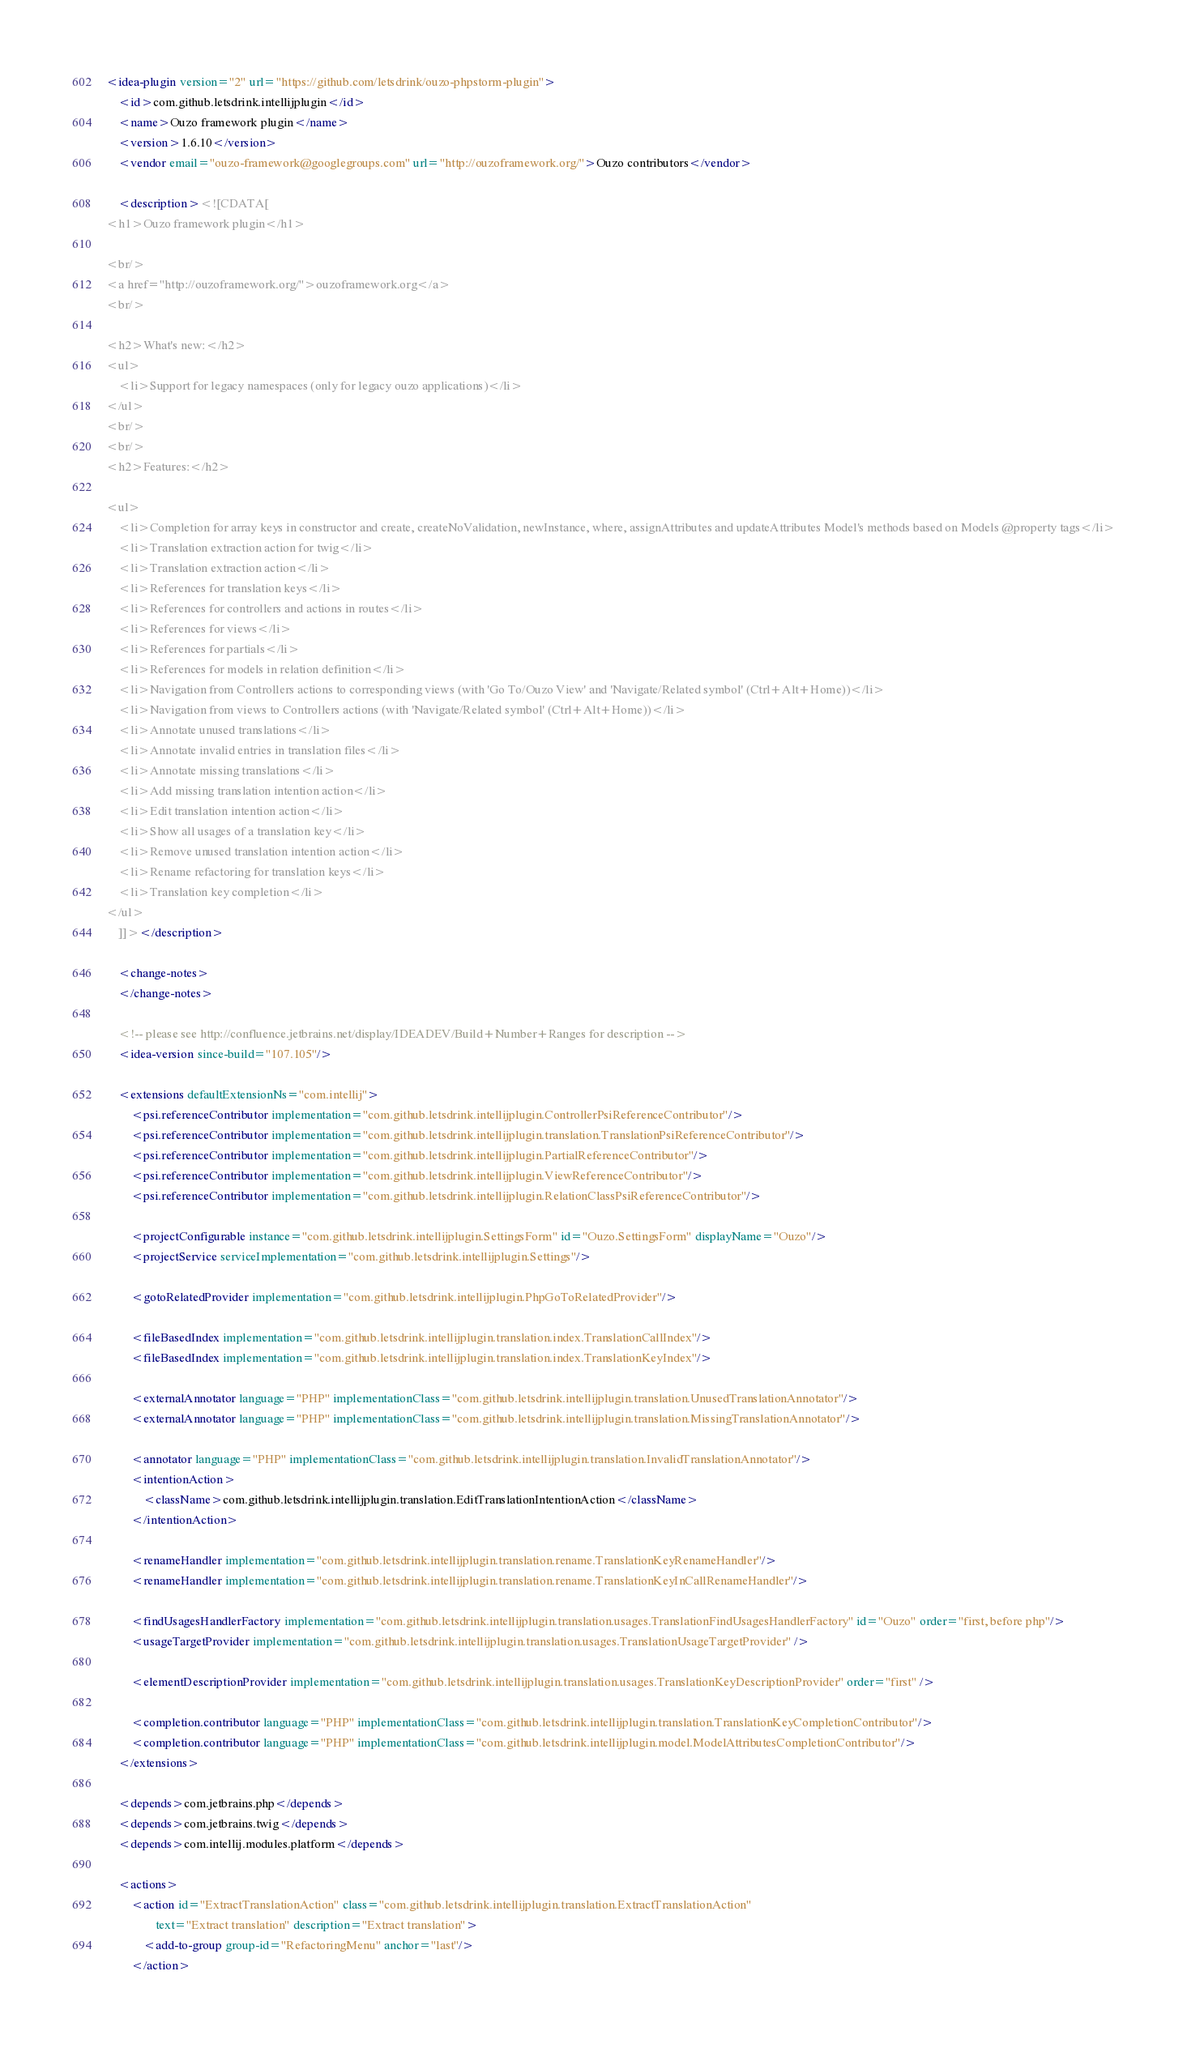Convert code to text. <code><loc_0><loc_0><loc_500><loc_500><_XML_><idea-plugin version="2" url="https://github.com/letsdrink/ouzo-phpstorm-plugin">
    <id>com.github.letsdrink.intellijplugin</id>
    <name>Ouzo framework plugin</name>
    <version>1.6.10</version>
    <vendor email="ouzo-framework@googlegroups.com" url="http://ouzoframework.org/">Ouzo contributors</vendor>

    <description><![CDATA[
<h1>Ouzo framework plugin</h1>

<br/>
<a href="http://ouzoframework.org/">ouzoframework.org</a>
<br/>

<h2>What's new:</h2>
<ul>
    <li>Support for legacy namespaces (only for legacy ouzo applications)</li>
</ul>
<br/>
<br/>
<h2>Features:</h2>

<ul>
    <li>Completion for array keys in constructor and create, createNoValidation, newInstance, where, assignAttributes and updateAttributes Model's methods based on Models @property tags</li>
    <li>Translation extraction action for twig</li>
    <li>Translation extraction action</li>
    <li>References for translation keys</li>
    <li>References for controllers and actions in routes</li>
    <li>References for views</li>
    <li>References for partials</li>
    <li>References for models in relation definition</li>
    <li>Navigation from Controllers actions to corresponding views (with 'Go To/Ouzo View' and 'Navigate/Related symbol' (Ctrl+Alt+Home))</li>
    <li>Navigation from views to Controllers actions (with 'Navigate/Related symbol' (Ctrl+Alt+Home))</li>
    <li>Annotate unused translations</li>
    <li>Annotate invalid entries in translation files</li>
    <li>Annotate missing translations</li>
    <li>Add missing translation intention action</li>
    <li>Edit translation intention action</li>
    <li>Show all usages of a translation key</li>
    <li>Remove unused translation intention action</li>
    <li>Rename refactoring for translation keys</li>
    <li>Translation key completion</li>
</ul>
    ]]></description>

    <change-notes>
    </change-notes>

    <!-- please see http://confluence.jetbrains.net/display/IDEADEV/Build+Number+Ranges for description -->
    <idea-version since-build="107.105"/>

    <extensions defaultExtensionNs="com.intellij">
        <psi.referenceContributor implementation="com.github.letsdrink.intellijplugin.ControllerPsiReferenceContributor"/>
        <psi.referenceContributor implementation="com.github.letsdrink.intellijplugin.translation.TranslationPsiReferenceContributor"/>
        <psi.referenceContributor implementation="com.github.letsdrink.intellijplugin.PartialReferenceContributor"/>
        <psi.referenceContributor implementation="com.github.letsdrink.intellijplugin.ViewReferenceContributor"/>
        <psi.referenceContributor implementation="com.github.letsdrink.intellijplugin.RelationClassPsiReferenceContributor"/>

        <projectConfigurable instance="com.github.letsdrink.intellijplugin.SettingsForm" id="Ouzo.SettingsForm" displayName="Ouzo"/>
        <projectService serviceImplementation="com.github.letsdrink.intellijplugin.Settings"/>

        <gotoRelatedProvider implementation="com.github.letsdrink.intellijplugin.PhpGoToRelatedProvider"/>

        <fileBasedIndex implementation="com.github.letsdrink.intellijplugin.translation.index.TranslationCallIndex"/>
        <fileBasedIndex implementation="com.github.letsdrink.intellijplugin.translation.index.TranslationKeyIndex"/>

        <externalAnnotator language="PHP" implementationClass="com.github.letsdrink.intellijplugin.translation.UnusedTranslationAnnotator"/>
        <externalAnnotator language="PHP" implementationClass="com.github.letsdrink.intellijplugin.translation.MissingTranslationAnnotator"/>

        <annotator language="PHP" implementationClass="com.github.letsdrink.intellijplugin.translation.InvalidTranslationAnnotator"/>
        <intentionAction>
            <className>com.github.letsdrink.intellijplugin.translation.EditTranslationIntentionAction</className>
        </intentionAction>

        <renameHandler implementation="com.github.letsdrink.intellijplugin.translation.rename.TranslationKeyRenameHandler"/>
        <renameHandler implementation="com.github.letsdrink.intellijplugin.translation.rename.TranslationKeyInCallRenameHandler"/>

        <findUsagesHandlerFactory implementation="com.github.letsdrink.intellijplugin.translation.usages.TranslationFindUsagesHandlerFactory" id="Ouzo" order="first, before php"/>
        <usageTargetProvider implementation="com.github.letsdrink.intellijplugin.translation.usages.TranslationUsageTargetProvider" />

        <elementDescriptionProvider implementation="com.github.letsdrink.intellijplugin.translation.usages.TranslationKeyDescriptionProvider" order="first" />

        <completion.contributor language="PHP" implementationClass="com.github.letsdrink.intellijplugin.translation.TranslationKeyCompletionContributor"/>
        <completion.contributor language="PHP" implementationClass="com.github.letsdrink.intellijplugin.model.ModelAttributesCompletionContributor"/>
    </extensions>

    <depends>com.jetbrains.php</depends>
    <depends>com.jetbrains.twig</depends>
    <depends>com.intellij.modules.platform</depends>

    <actions>
        <action id="ExtractTranslationAction" class="com.github.letsdrink.intellijplugin.translation.ExtractTranslationAction"
                text="Extract translation" description="Extract translation">
            <add-to-group group-id="RefactoringMenu" anchor="last"/>
        </action>
</code> 